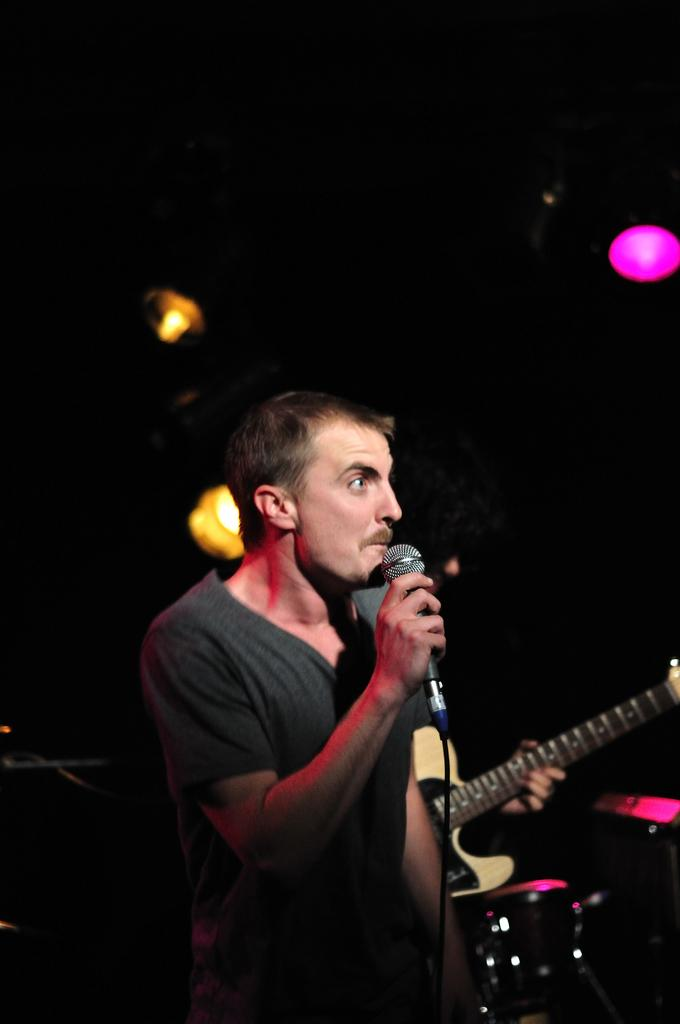What is the man in the image doing? The man is holding a microphone and talking. What is the man wearing in the image? The man is wearing a black color t-shirt. What object is the man holding in his hands? The man is holding a guitar in his hands. What type of food is the man eating in the image? There is no food present in the image; the man is holding a microphone and a guitar. Can you see any goldfish swimming in the image? There are no goldfish present in the image. 